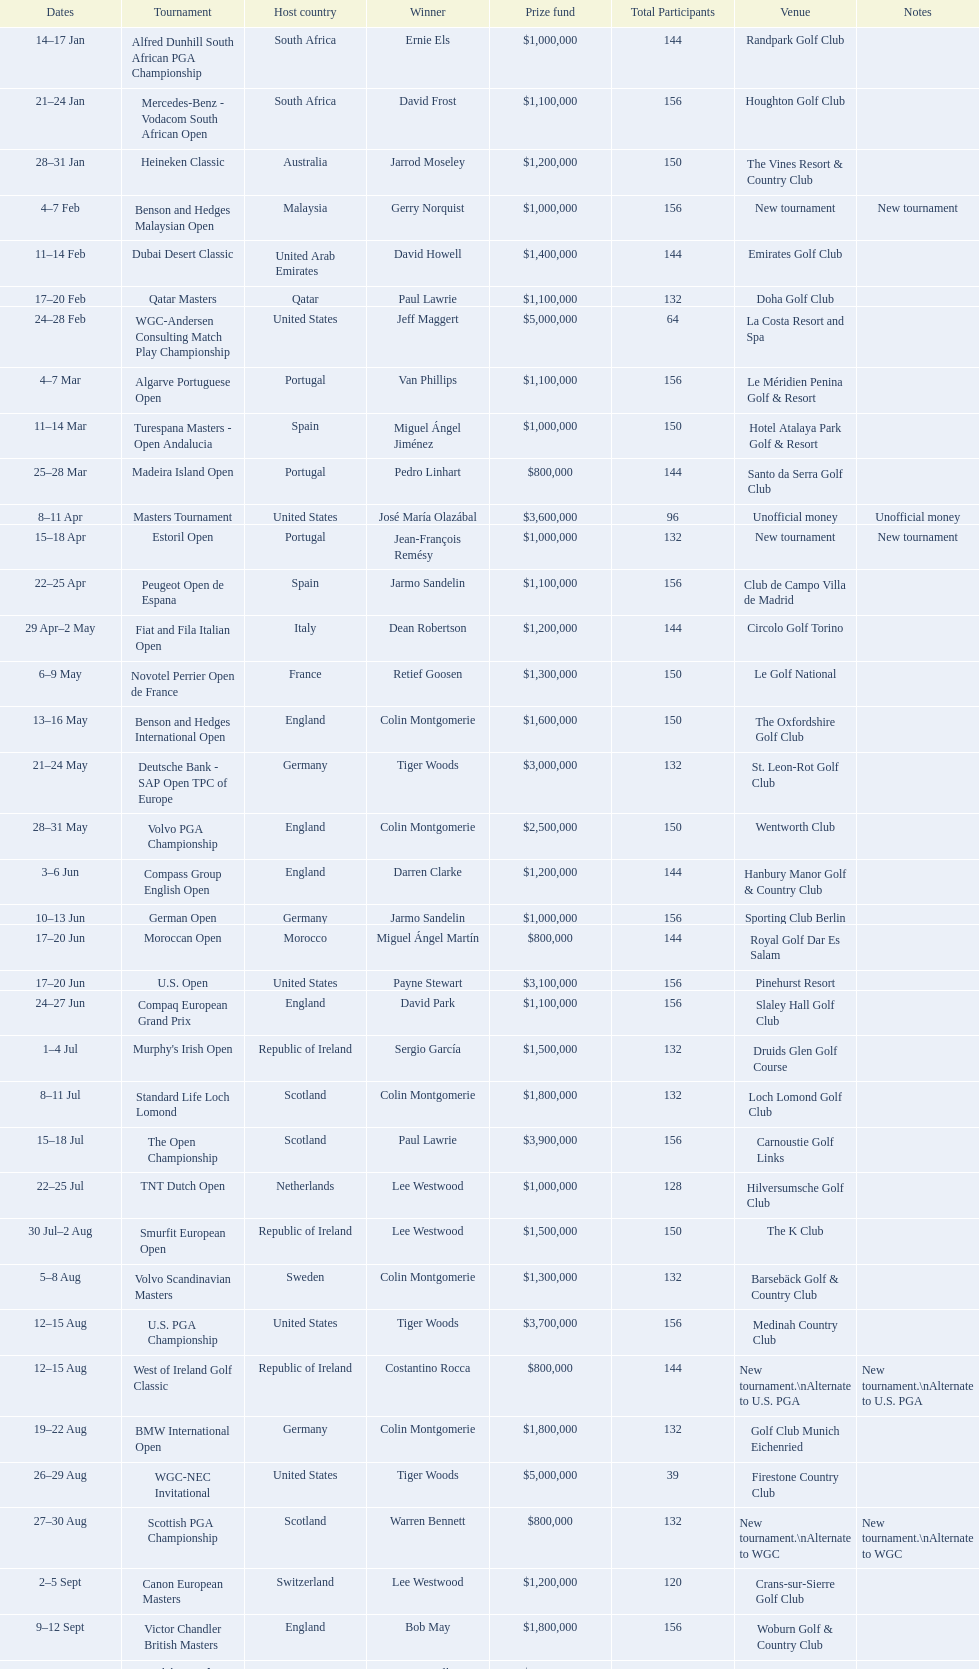Does any country have more than 5 winners? Yes. 